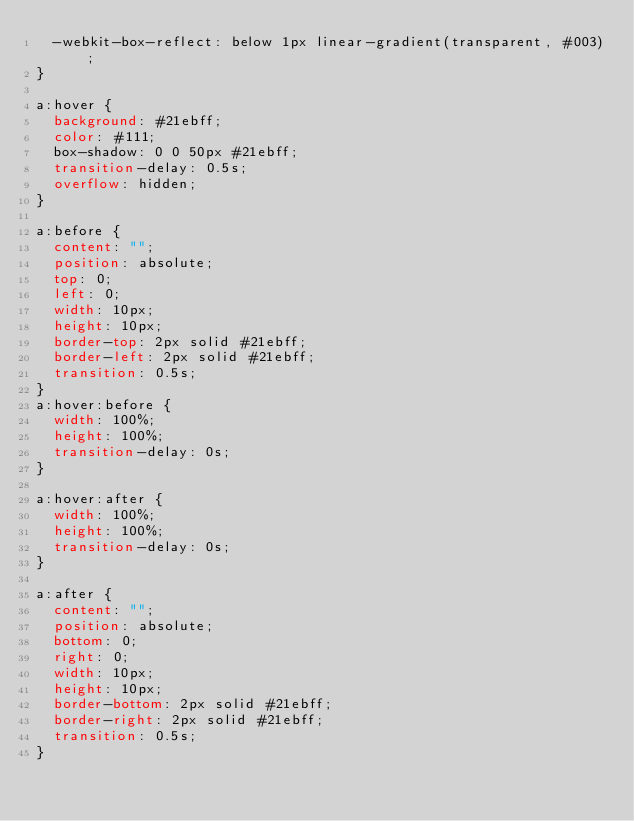Convert code to text. <code><loc_0><loc_0><loc_500><loc_500><_CSS_>  -webkit-box-reflect: below 1px linear-gradient(transparent, #003);
}

a:hover {
  background: #21ebff;
  color: #111;
  box-shadow: 0 0 50px #21ebff;
  transition-delay: 0.5s;
  overflow: hidden;
}

a:before {
  content: "";
  position: absolute;
  top: 0;
  left: 0;
  width: 10px;
  height: 10px;
  border-top: 2px solid #21ebff;
  border-left: 2px solid #21ebff;
  transition: 0.5s;
}
a:hover:before {
  width: 100%;
  height: 100%;
  transition-delay: 0s;
}

a:hover:after {
  width: 100%;
  height: 100%;
  transition-delay: 0s;
}

a:after {
  content: "";
  position: absolute;
  bottom: 0;
  right: 0;
  width: 10px;
  height: 10px;
  border-bottom: 2px solid #21ebff;
  border-right: 2px solid #21ebff;
  transition: 0.5s;
}
</code> 